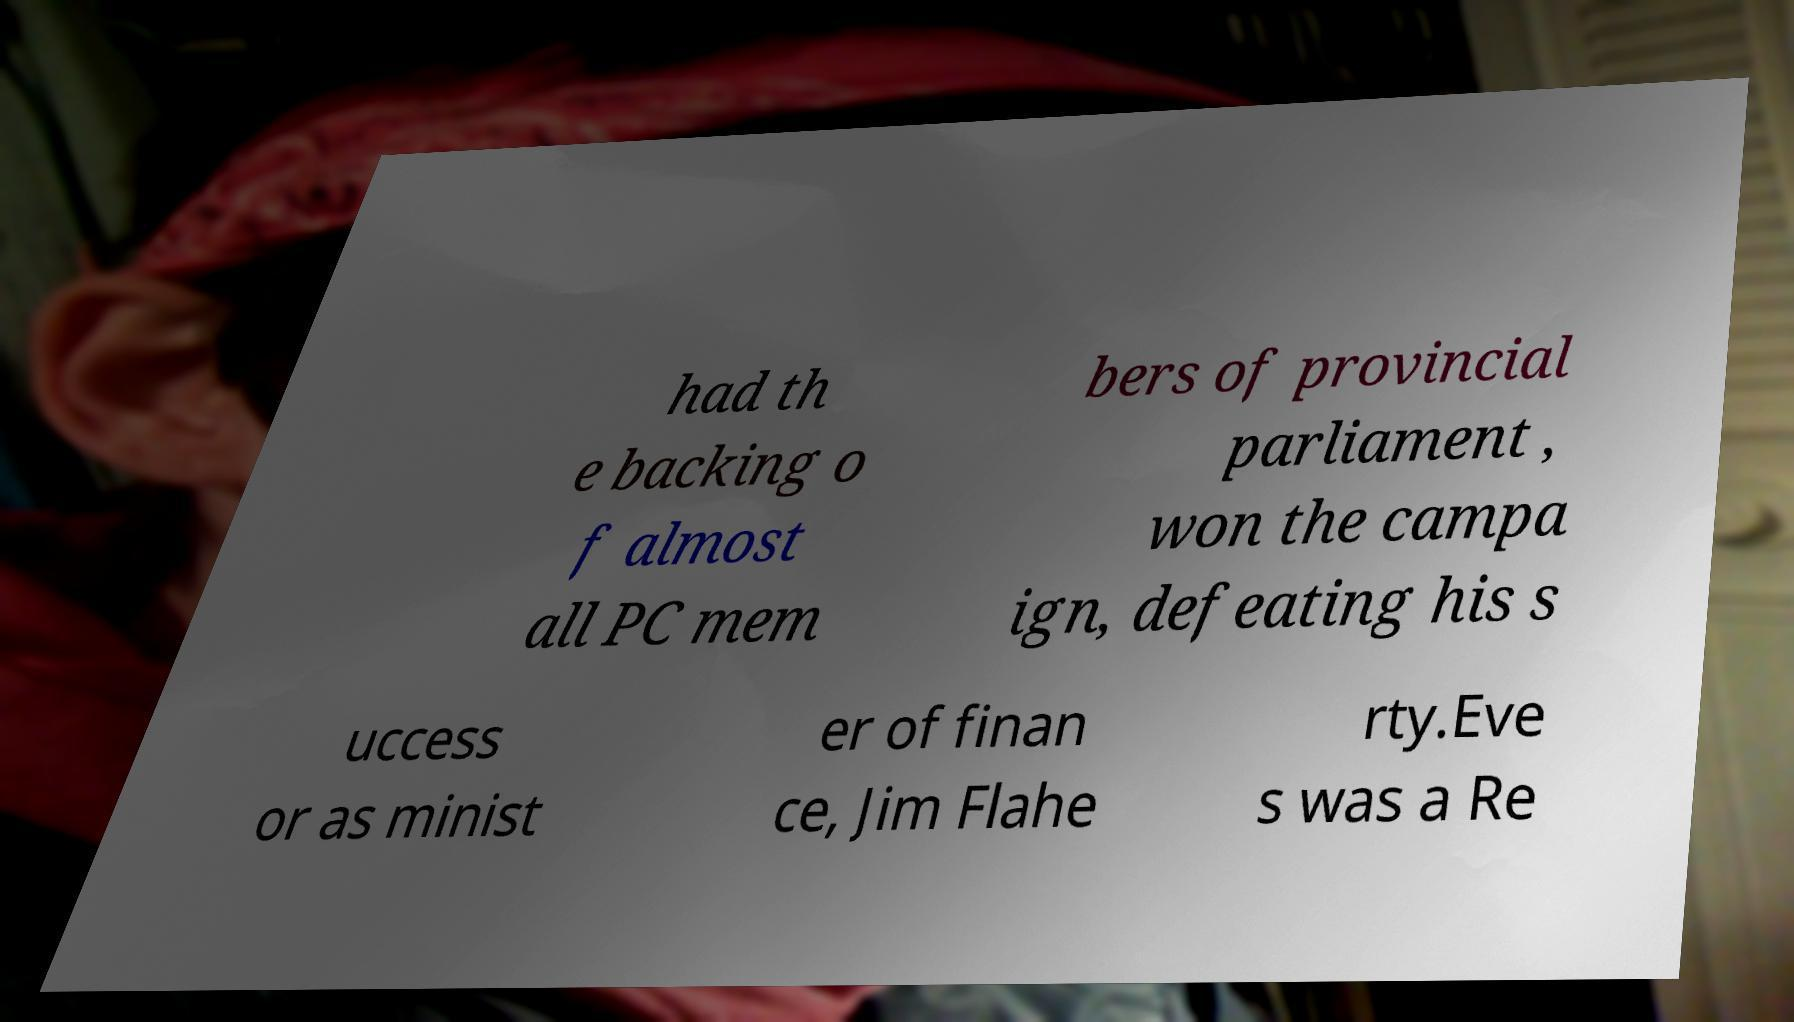Please read and relay the text visible in this image. What does it say? had th e backing o f almost all PC mem bers of provincial parliament , won the campa ign, defeating his s uccess or as minist er of finan ce, Jim Flahe rty.Eve s was a Re 